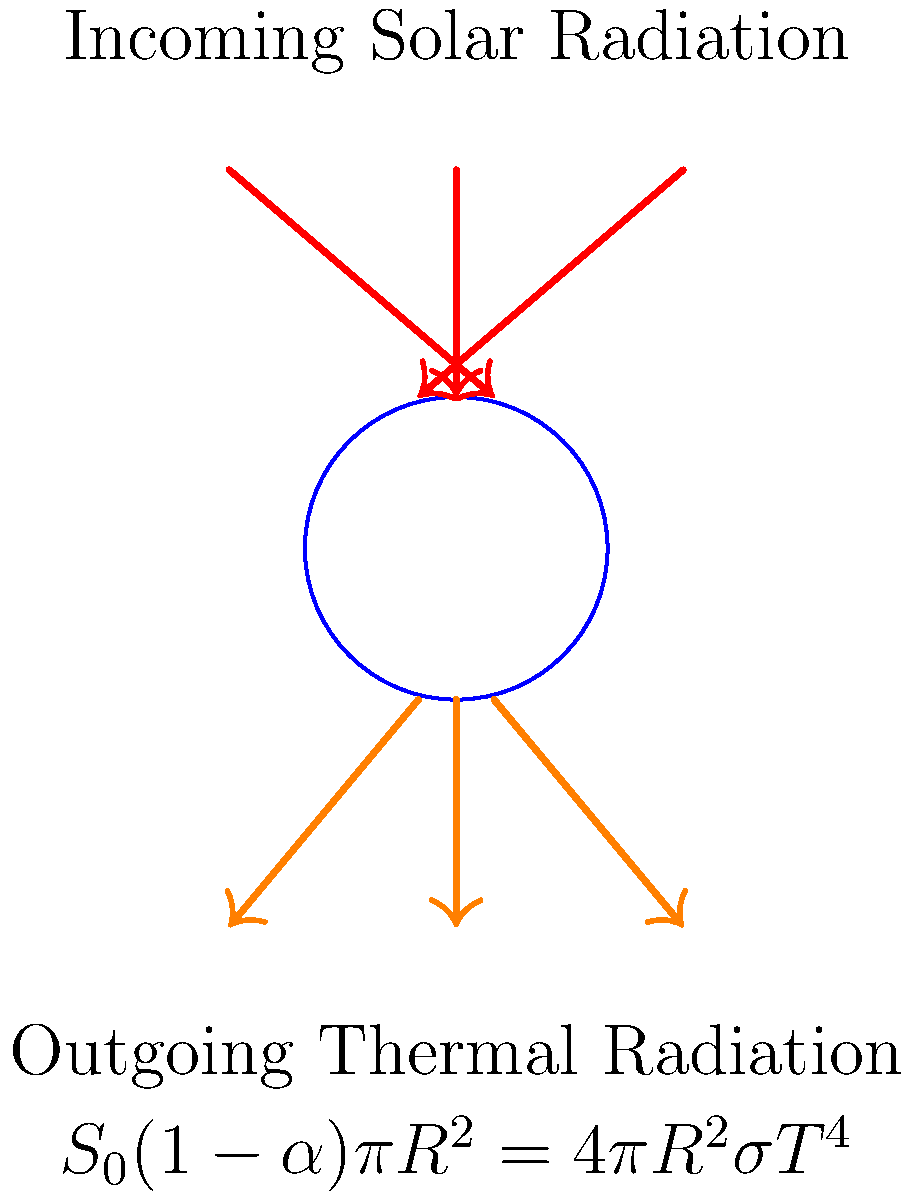Given the Earth's energy balance diagram, if the solar constant $S_0 = 1361 \text{ W/m}^2$, Earth's albedo $\alpha = 0.3$, and Stefan-Boltzmann constant $\sigma = 5.67 \times 10^{-8} \text{ W/m}^2\text{K}^4$, calculate the Earth's effective temperature $T$ in Kelvin. Assume the Earth is in radiative equilibrium and behaves as a perfect blackbody. To solve this problem, we'll use the Earth's energy balance equation shown in the diagram:

$S_0(1-\alpha)\pi R^2 = 4\pi R^2\sigma T^4$

1) First, we can simplify this equation by canceling out $\pi R^2$ on both sides:

   $S_0(1-\alpha) = 4\sigma T^4$

2) Now, let's substitute the known values:
   $S_0 = 1361 \text{ W/m}^2$
   $\alpha = 0.3$
   $\sigma = 5.67 \times 10^{-8} \text{ W/m}^2\text{K}^4$

3) Plugging these into our equation:

   $1361(1-0.3) = 4(5.67 \times 10^{-8})T^4$

4) Simplify the left side:

   $1361 \times 0.7 = 4(5.67 \times 10^{-8})T^4$
   $952.7 = 2.268 \times 10^{-7}T^4$

5) Divide both sides by $2.268 \times 10^{-7}$:

   $\frac{952.7}{2.268 \times 10^{-7}} = T^4$
   $4.2 \times 10^9 = T^4$

6) Take the fourth root of both sides:

   $T = \sqrt[4]{4.2 \times 10^9}$

7) Calculate the final result:

   $T \approx 255.4 \text{ K}$
Answer: 255.4 K 